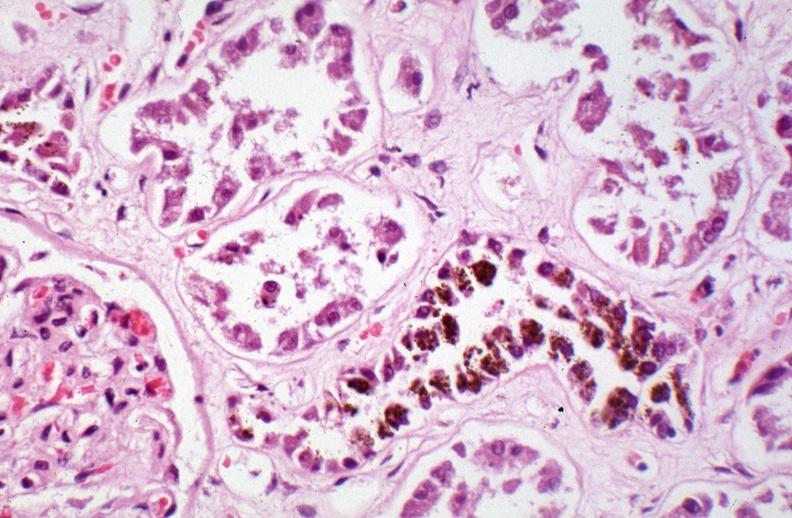what caused by numerous blood transfusions?
Answer the question using a single word or phrase. Hemosiderosis 